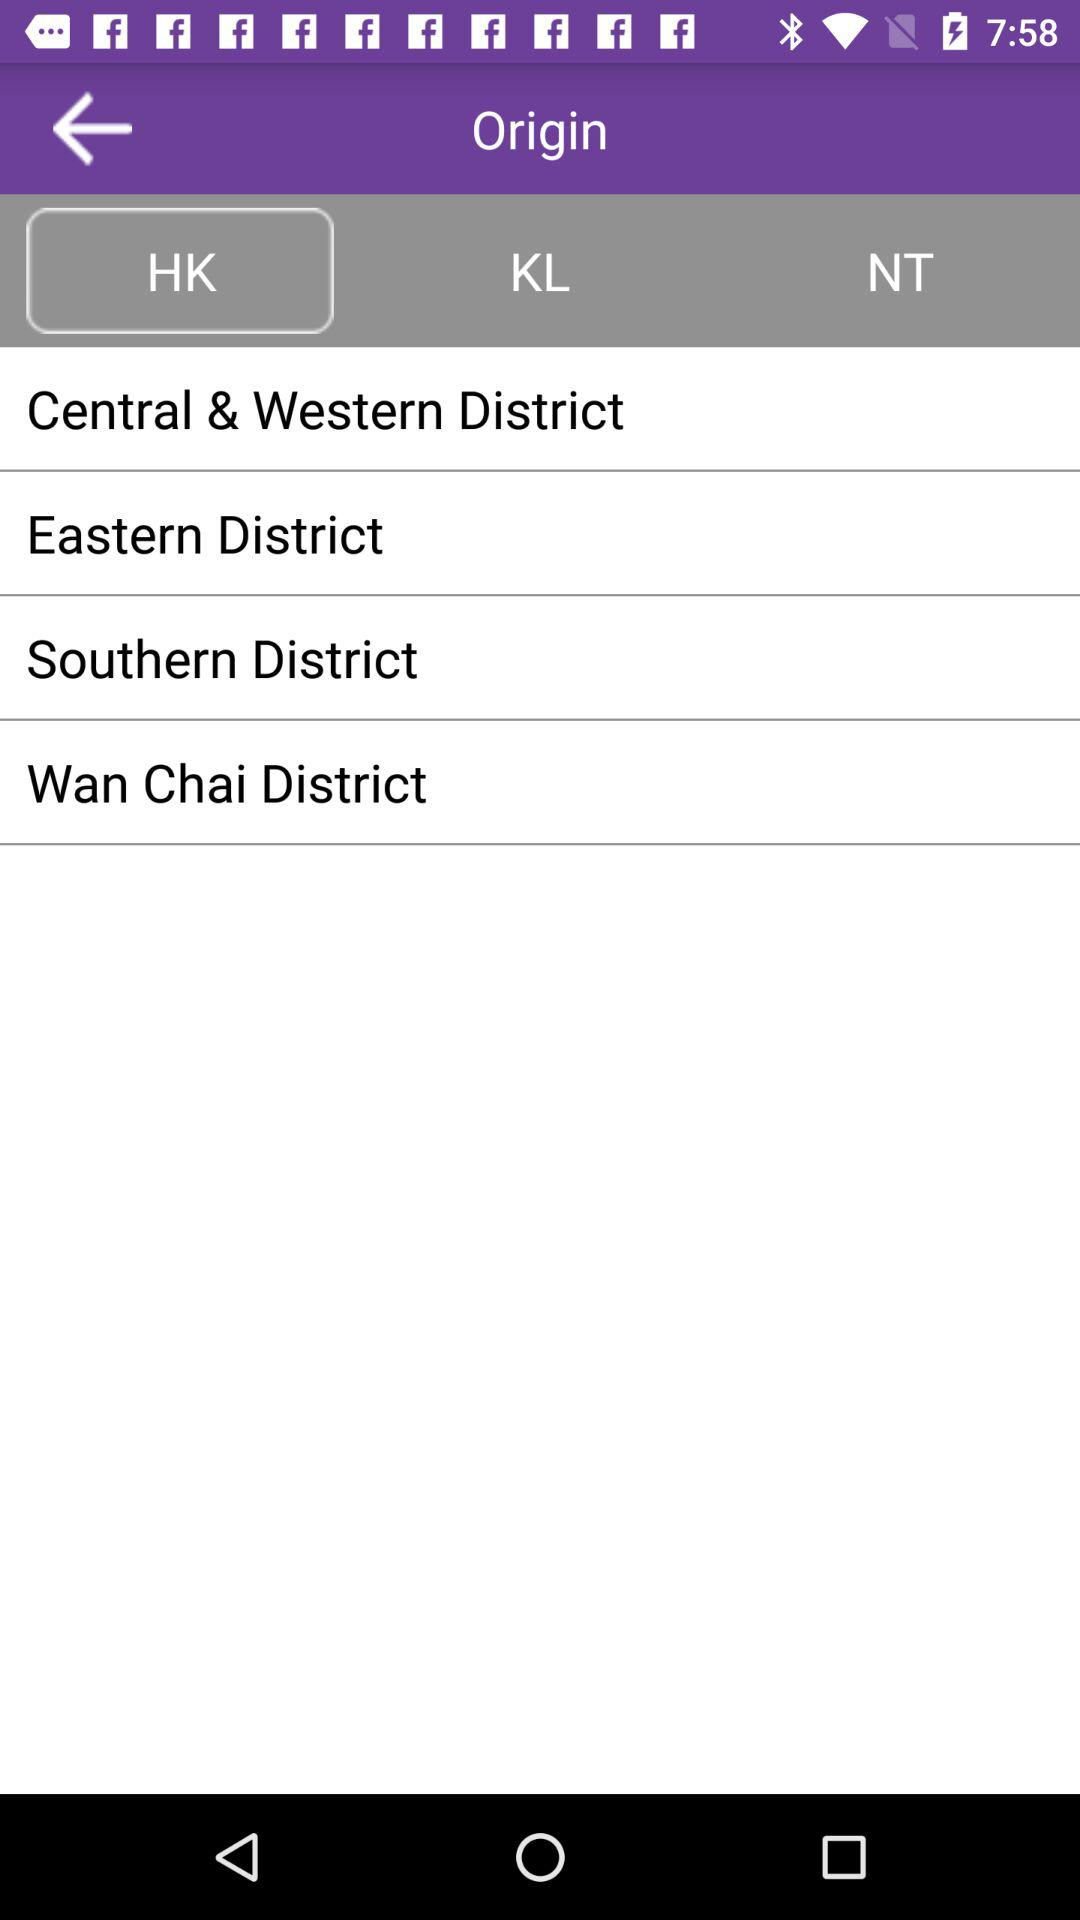Which tab is selected? The selected tab is "HK". 